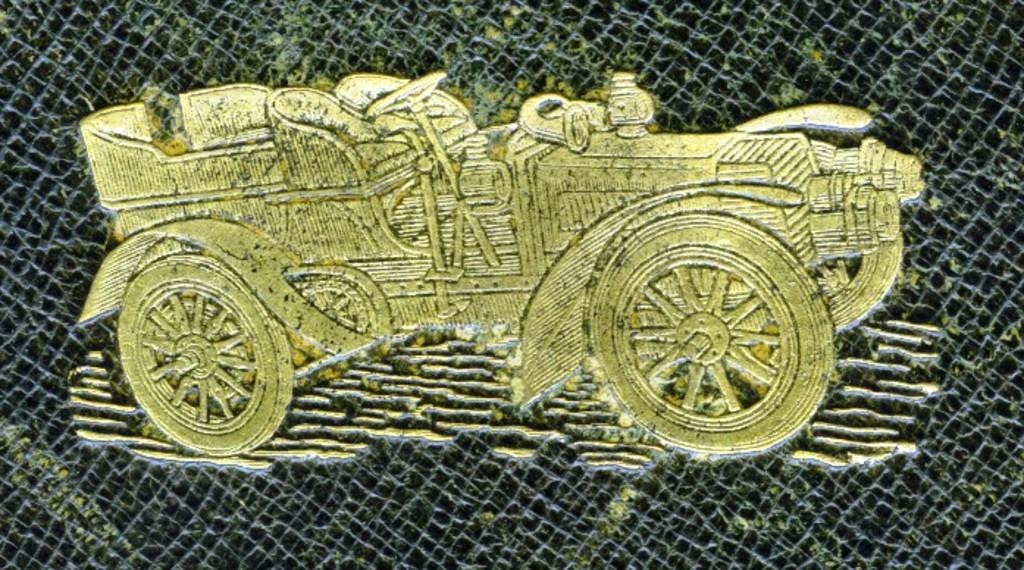What is the main subject of the picture? The main subject of the picture is an image of a car. What is the color of the car image? The car image is in golden color. What is the background color of the car image? The car image is printed on a black surface. How much wealth is represented by the car image in the picture? The image of the car does not represent any specific amount of wealth; it is simply an image of a car in a golden color on a black surface. 